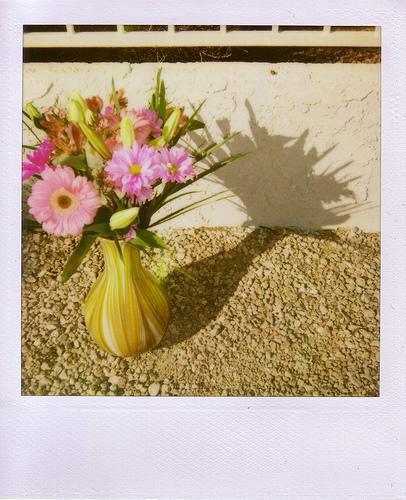How many empty vases are there?
Give a very brief answer. 0. 